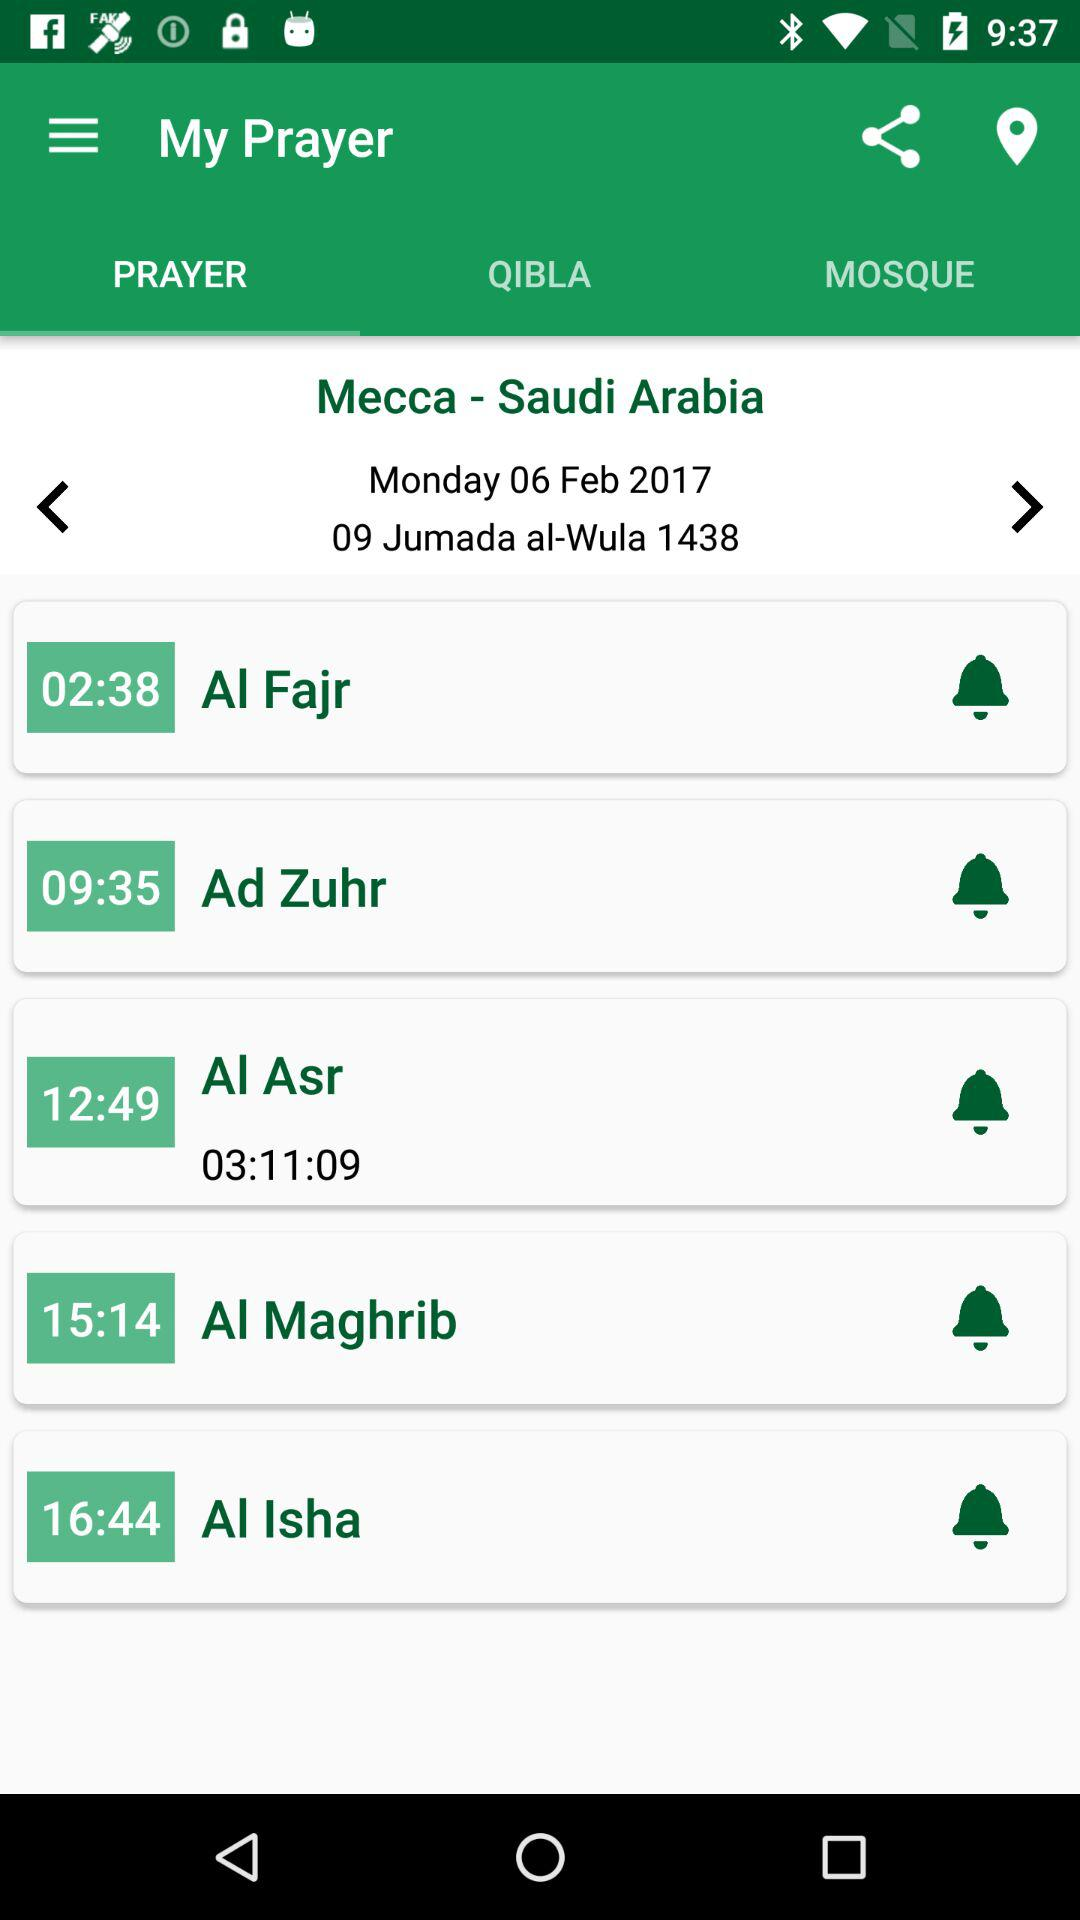What is the location? The location is Mecca, Saudi Arabia. 